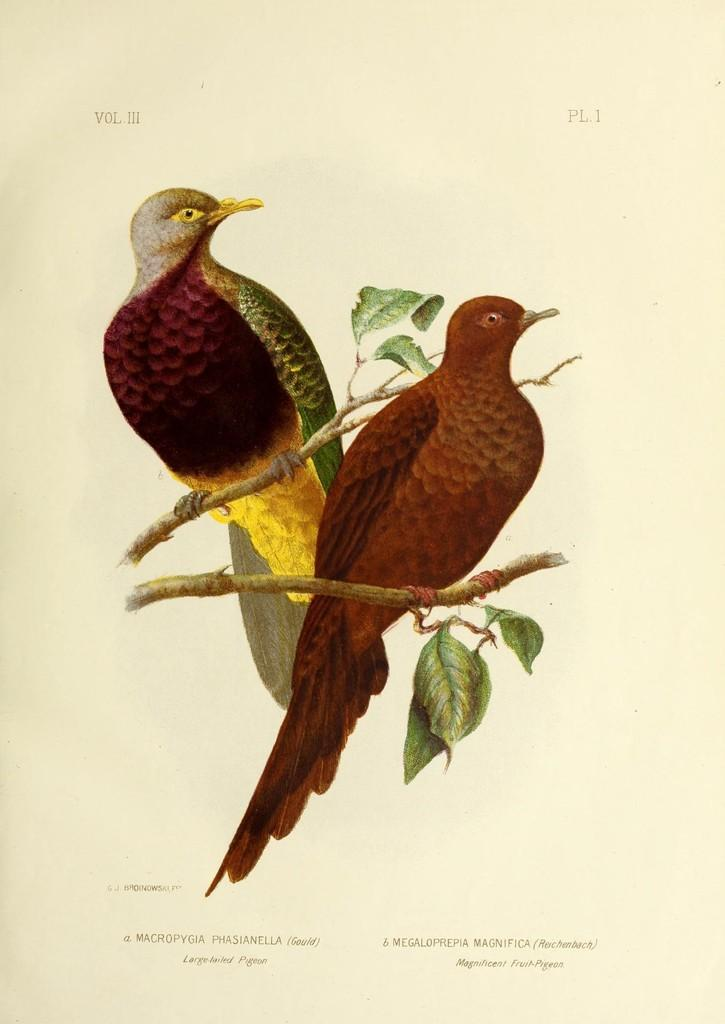What is depicted on the poster in the image? The poster contains two birds in the image. Where are the birds located on the poster? The birds are standing on a tree branch. What else can be seen in the image besides the birds? Leaves are visible in the image. Is there any information about the creator of the poster in the image? Yes, the author's name is present at the bottom of the poster. What type of card is the skirt made of in the image? There is no card or skirt present in the image; it features a poster with two birds on a tree branch. 